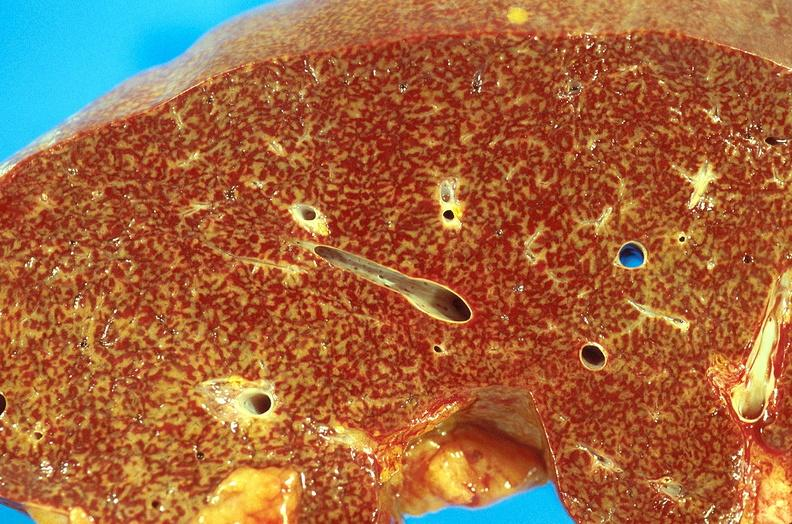what does this image show?
Answer the question using a single word or phrase. Chronic passive congestion 